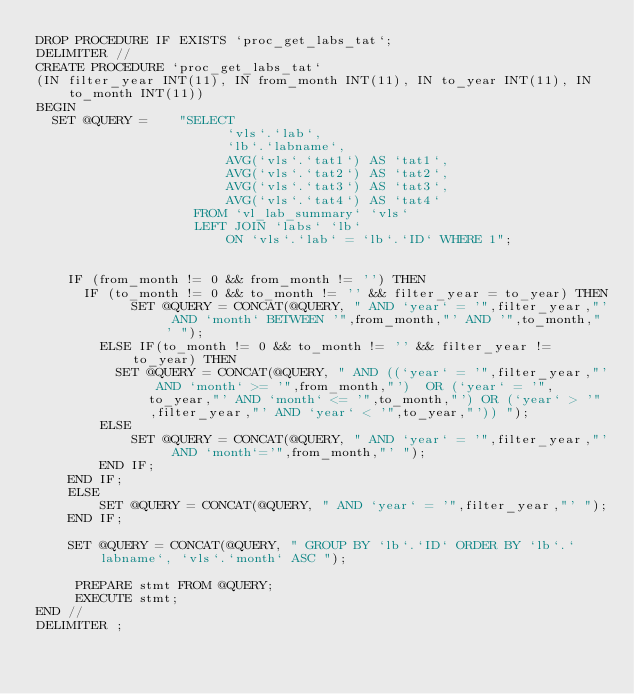<code> <loc_0><loc_0><loc_500><loc_500><_SQL_>DROP PROCEDURE IF EXISTS `proc_get_labs_tat`;
DELIMITER //
CREATE PROCEDURE `proc_get_labs_tat`
(IN filter_year INT(11), IN from_month INT(11), IN to_year INT(11), IN to_month INT(11))
BEGIN
  SET @QUERY =    "SELECT 
                        `vls`.`lab`, 
                        `lb`.`labname`, 
                        AVG(`vls`.`tat1`) AS `tat1`, 
                        AVG(`vls`.`tat2`) AS `tat2`, 
                        AVG(`vls`.`tat3`) AS `tat3`, 
                        AVG(`vls`.`tat4`) AS `tat4` 
                    FROM `vl_lab_summary` `vls` 
                    LEFT JOIN `labs` `lb` 
                        ON `vls`.`lab` = `lb`.`ID` WHERE 1";

   
    IF (from_month != 0 && from_month != '') THEN
      IF (to_month != 0 && to_month != '' && filter_year = to_year) THEN
            SET @QUERY = CONCAT(@QUERY, " AND `year` = '",filter_year,"' AND `month` BETWEEN '",from_month,"' AND '",to_month,"' ");
        ELSE IF(to_month != 0 && to_month != '' && filter_year != to_year) THEN
          SET @QUERY = CONCAT(@QUERY, " AND ((`year` = '",filter_year,"' AND `month` >= '",from_month,"')  OR (`year` = '",to_year,"' AND `month` <= '",to_month,"') OR (`year` > '",filter_year,"' AND `year` < '",to_year,"')) ");
        ELSE
            SET @QUERY = CONCAT(@QUERY, " AND `year` = '",filter_year,"' AND `month`='",from_month,"' ");
        END IF;
    END IF;
    ELSE
        SET @QUERY = CONCAT(@QUERY, " AND `year` = '",filter_year,"' ");
    END IF;

    SET @QUERY = CONCAT(@QUERY, " GROUP BY `lb`.`ID` ORDER BY `lb`.`labname`, `vls`.`month` ASC ");

     PREPARE stmt FROM @QUERY;
     EXECUTE stmt;
END //
DELIMITER ;
</code> 